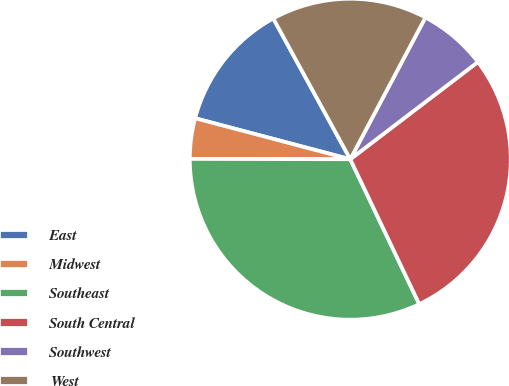Convert chart to OTSL. <chart><loc_0><loc_0><loc_500><loc_500><pie_chart><fcel>East<fcel>Midwest<fcel>Southeast<fcel>South Central<fcel>Southwest<fcel>West<nl><fcel>12.92%<fcel>4.08%<fcel>32.1%<fcel>28.29%<fcel>6.88%<fcel>15.72%<nl></chart> 